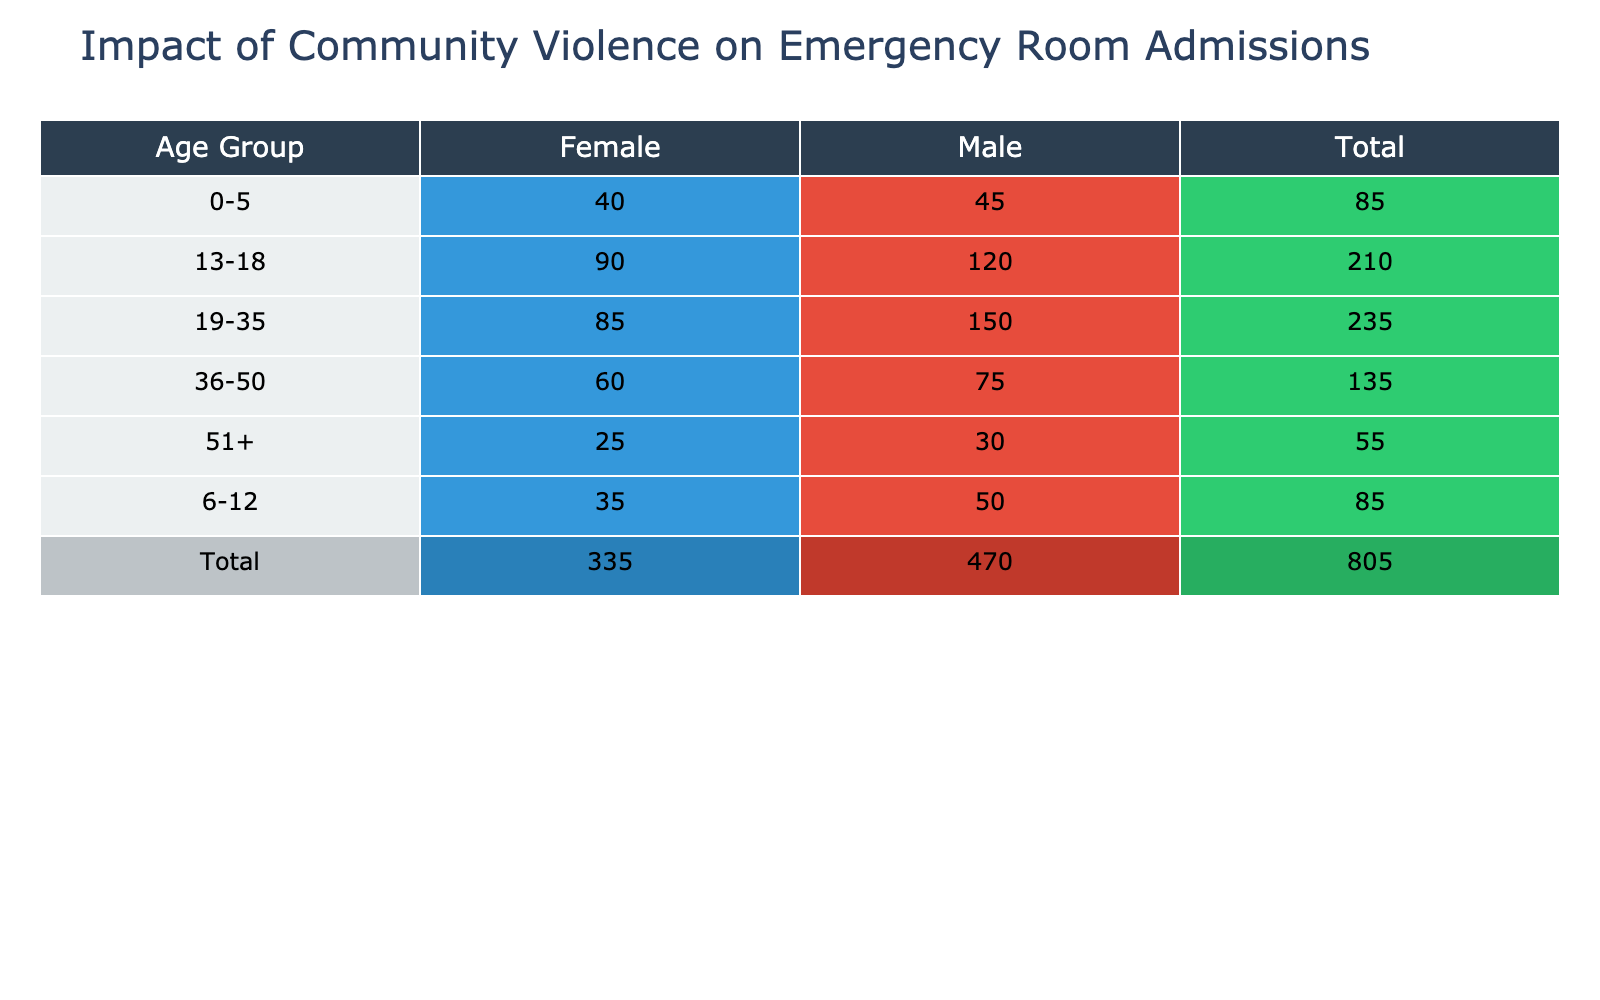What is the total number of emergency room admissions for males aged 19-35? The table shows that male admissions for the age group 19-35 are 150. No additional calculations are needed.
Answer: 150 How many more emergency room admissions did males aged 13-18 have compared to females in the same age group? Males aged 13-18 had 120 admissions and females had 90. The difference is 120 - 90 = 30.
Answer: 30 What is the total number of emergency room admissions for females across all age groups? By summing up the female admissions: 40 (0-5) + 35 (6-12) + 90 (13-18) + 85 (19-35) + 60 (36-50) + 25 (51+) = 335.
Answer: 335 Are there more emergency room admissions for the 19-35 age group compared to the 36-50 age group for males? The admissions for males in the 19-35 age group is 150, while for the 36-50 age group it is 75. Since 150 is greater than 75, the statement is true.
Answer: Yes What percentage of total emergency room admissions for the age group 0-5 are male? The total admissions for age group 0-5 is 45 (male) + 40 (female) = 85. The percentage of male admissions is (45/85) * 100 = 52.94, which rounds to approximately 53%.
Answer: 53% How many total emergency room admissions were recorded for the age group 51+? Looking at the table, there were 30 admissions for males and 25 for females in the 51+ age group. Therefore, total admissions are 30 + 25 = 55.
Answer: 55 Is it true that the total number of male admissions (all age groups combined) is more than the total number of female admissions? The total male admissions are 45 + 50 + 120 + 150 + 75 + 30 = 470. The total female admissions are 40 + 35 + 90 + 85 + 60 + 25 = 335. Since 470 is greater than 335, this statement is true.
Answer: Yes What is the average number of emergency room admissions for males aged 6-12 and females aged 6-12? The male admissions in the 6-12 age group is 50 and female is 35. The average is (50 + 35) / 2 = 42.5.
Answer: 42.5 What is the total number of emergency room admissions across all age groups? Summing all admissions across age groups: 45 (0-5) + 40 + 50 (6-12) + 35 + 120 (13-18) + 90 + 150 (19-35) + 85 + 75 (36-50) + 60 + 30 (51+) + 25 =  1,025.
Answer: 1025 